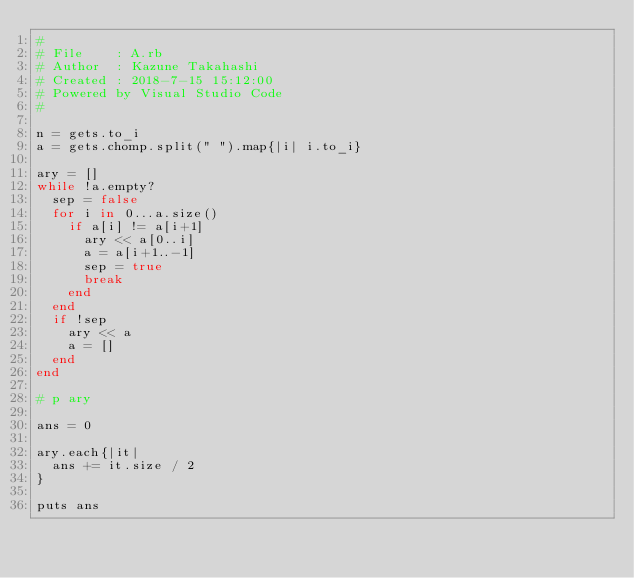<code> <loc_0><loc_0><loc_500><loc_500><_Ruby_>#
# File    : A.rb
# Author  : Kazune Takahashi
# Created : 2018-7-15 15:12:00
# Powered by Visual Studio Code
#

n = gets.to_i
a = gets.chomp.split(" ").map{|i| i.to_i}

ary = []
while !a.empty?
  sep = false
  for i in 0...a.size()
    if a[i] != a[i+1]
      ary << a[0..i]
      a = a[i+1..-1]
      sep = true
      break
    end
  end
  if !sep
    ary << a
    a = []
  end
end

# p ary

ans = 0

ary.each{|it|
  ans += it.size / 2
}

puts ans</code> 